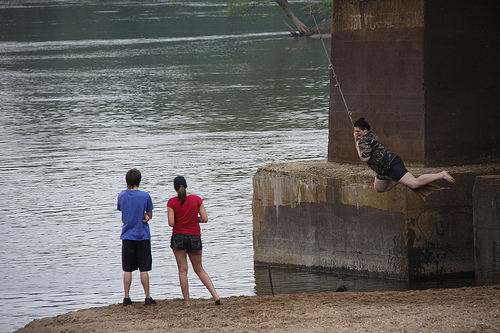<image>
Can you confirm if the woman is in the water? No. The woman is not contained within the water. These objects have a different spatial relationship. 